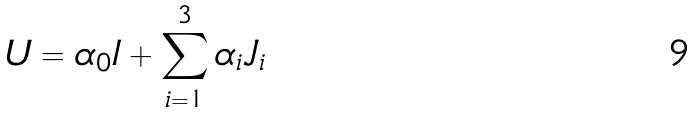<formula> <loc_0><loc_0><loc_500><loc_500>U = \alpha _ { 0 } I + \sum _ { i = 1 } ^ { 3 } \alpha _ { i } J _ { i }</formula> 